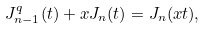<formula> <loc_0><loc_0><loc_500><loc_500>J _ { n - 1 } ^ { q } ( t ) + x J _ { n } ( t ) = J _ { n } ( x t ) ,</formula> 